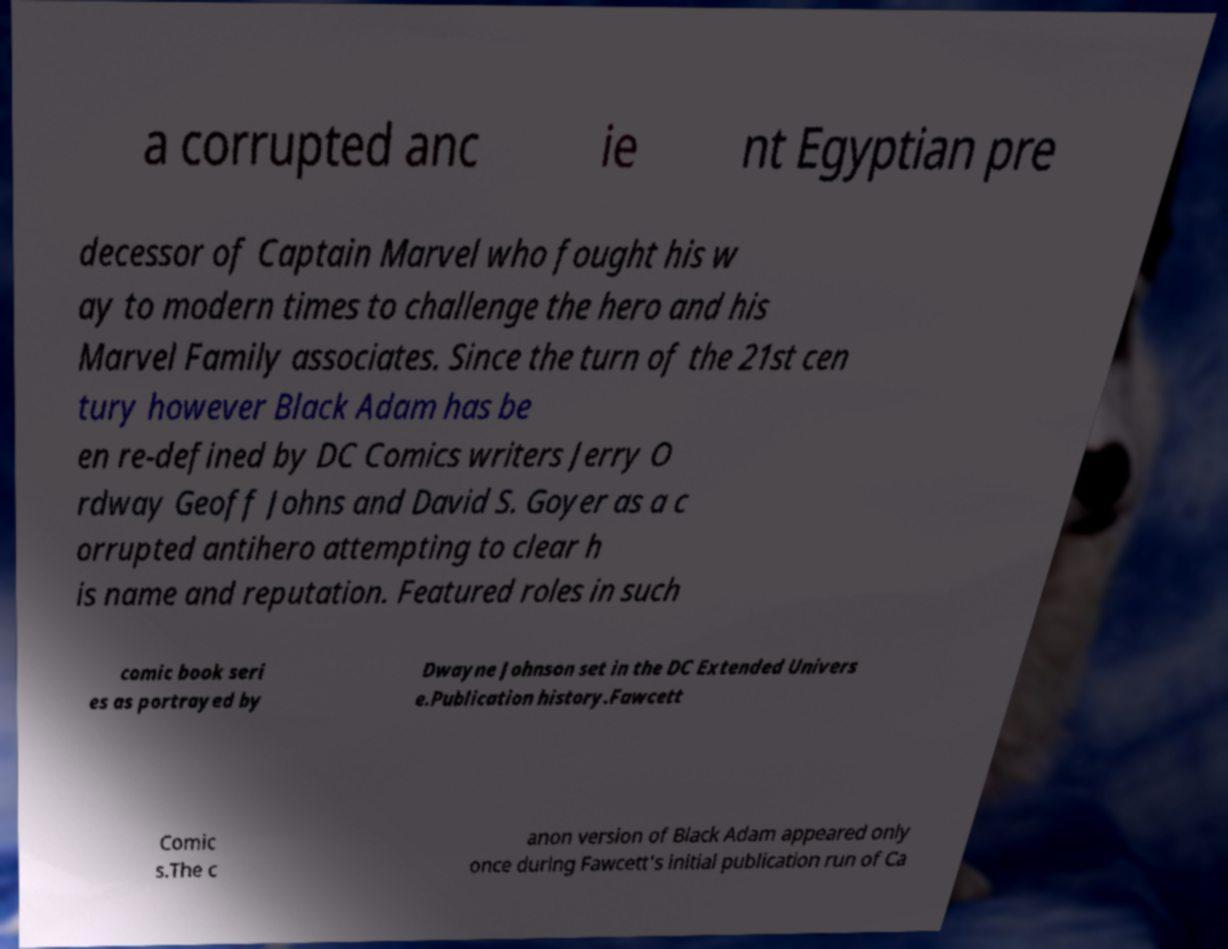There's text embedded in this image that I need extracted. Can you transcribe it verbatim? a corrupted anc ie nt Egyptian pre decessor of Captain Marvel who fought his w ay to modern times to challenge the hero and his Marvel Family associates. Since the turn of the 21st cen tury however Black Adam has be en re-defined by DC Comics writers Jerry O rdway Geoff Johns and David S. Goyer as a c orrupted antihero attempting to clear h is name and reputation. Featured roles in such comic book seri es as portrayed by Dwayne Johnson set in the DC Extended Univers e.Publication history.Fawcett Comic s.The c anon version of Black Adam appeared only once during Fawcett's initial publication run of Ca 